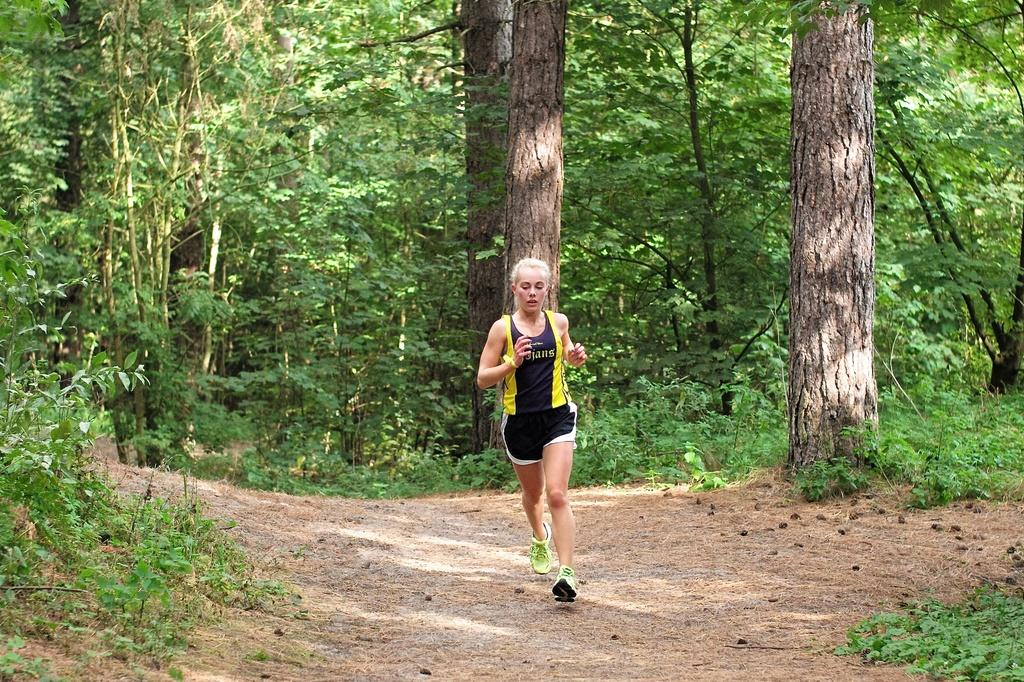What is the main subject of the image? There is a lady in the image. What type of clothing is the lady wearing? The lady is wearing a T-shirt and shorts. What type of surface is visible in the image? There is ground visible in the image. What type of vegetation can be seen in the image? There are plants, grass, and trees in the image. What type of dinner is being prepared in the image? There is no indication of dinner preparation in the image; it primarily features a lady and her clothing, as well as the surrounding environment. 